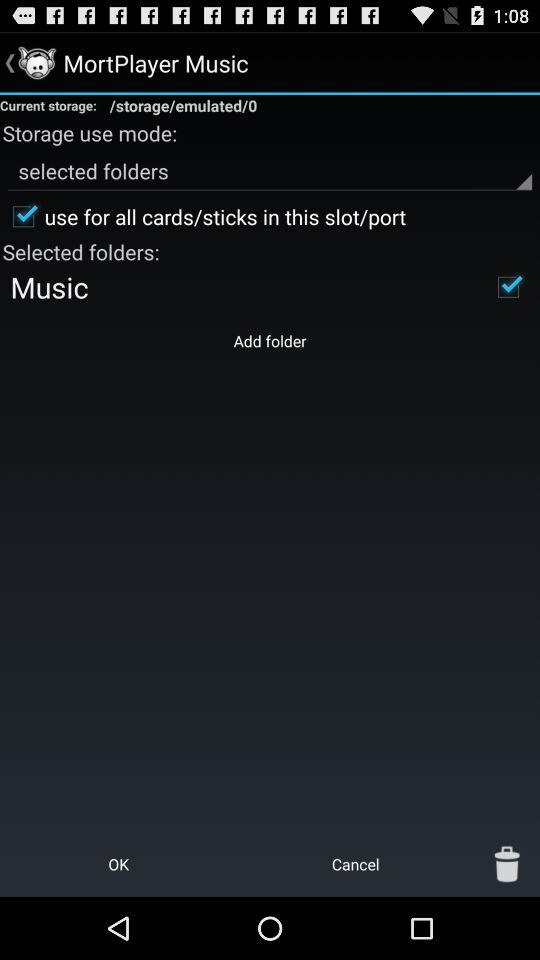Which option is marked as checked? The checked options are "use for all cards/sticks in this slot/port" and "Music". 